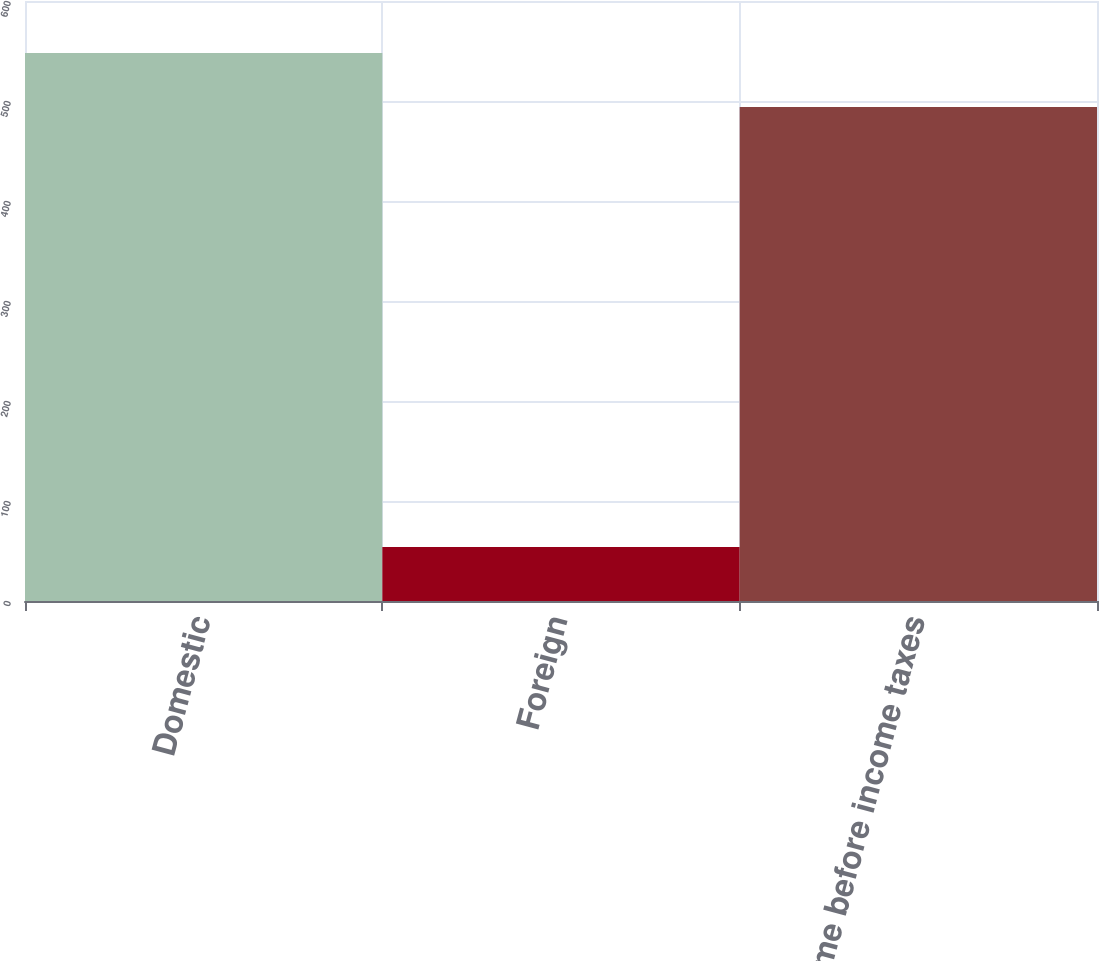Convert chart to OTSL. <chart><loc_0><loc_0><loc_500><loc_500><bar_chart><fcel>Domestic<fcel>Foreign<fcel>Income before income taxes<nl><fcel>548<fcel>54<fcel>494<nl></chart> 